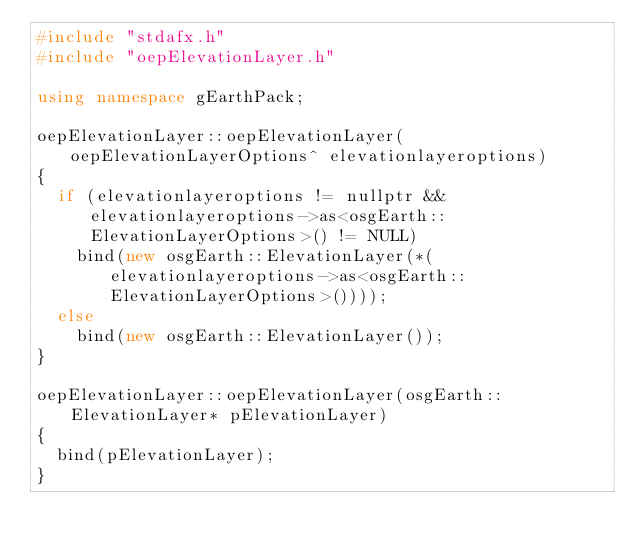Convert code to text. <code><loc_0><loc_0><loc_500><loc_500><_C++_>#include "stdafx.h"
#include "oepElevationLayer.h"

using namespace gEarthPack;

oepElevationLayer::oepElevationLayer(oepElevationLayerOptions^ elevationlayeroptions)
{
	if (elevationlayeroptions != nullptr && elevationlayeroptions->as<osgEarth::ElevationLayerOptions>() != NULL)
		bind(new osgEarth::ElevationLayer(*(elevationlayeroptions->as<osgEarth::ElevationLayerOptions>())));
	else
		bind(new osgEarth::ElevationLayer());
}

oepElevationLayer::oepElevationLayer(osgEarth::ElevationLayer* pElevationLayer)
{
	bind(pElevationLayer);
}



</code> 